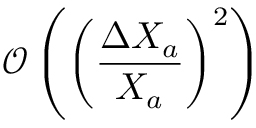<formula> <loc_0><loc_0><loc_500><loc_500>\mathcal { O } \left ( \left ( \frac { \Delta X _ { a } } { X _ { a } } \right ) ^ { 2 } \right )</formula> 